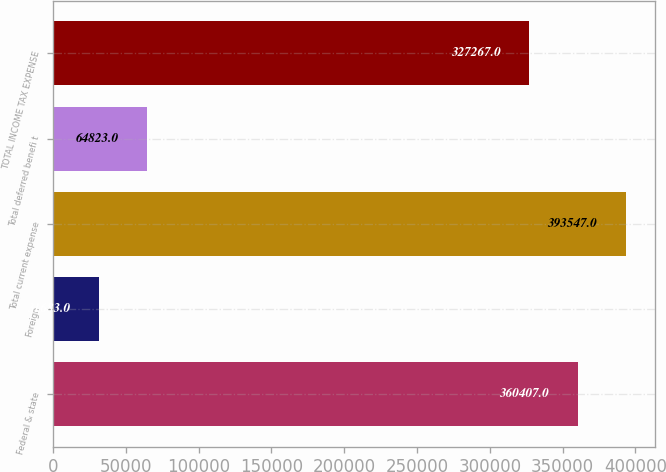<chart> <loc_0><loc_0><loc_500><loc_500><bar_chart><fcel>Federal & state<fcel>Foreign<fcel>Total current expense<fcel>Total deferred benefi t<fcel>TOTAL INCOME TAX EXPENSE<nl><fcel>360407<fcel>31683<fcel>393547<fcel>64823<fcel>327267<nl></chart> 